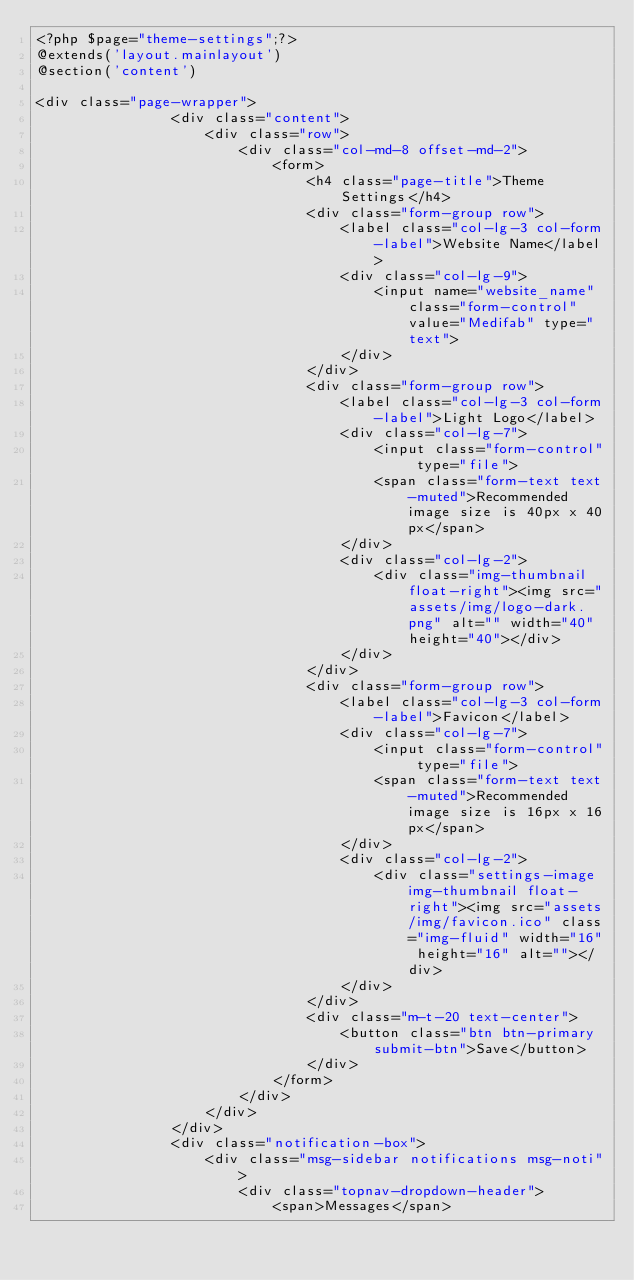Convert code to text. <code><loc_0><loc_0><loc_500><loc_500><_PHP_><?php $page="theme-settings";?>
@extends('layout.mainlayout')
@section('content')		

<div class="page-wrapper">
				<div class="content">
					<div class="row">
						<div class="col-md-8 offset-md-2">
							<form>
								<h4 class="page-title">Theme Settings</h4>
								<div class="form-group row">
									<label class="col-lg-3 col-form-label">Website Name</label>
									<div class="col-lg-9">
										<input name="website_name" class="form-control" value="Medifab" type="text">
									</div>
								</div>
								<div class="form-group row">
									<label class="col-lg-3 col-form-label">Light Logo</label>
									<div class="col-lg-7">
										<input class="form-control" type="file">
										<span class="form-text text-muted">Recommended image size is 40px x 40px</span>
									</div>
									<div class="col-lg-2">
										<div class="img-thumbnail float-right"><img src="assets/img/logo-dark.png" alt="" width="40" height="40"></div>
									</div>
								</div>
								<div class="form-group row">
									<label class="col-lg-3 col-form-label">Favicon</label>
									<div class="col-lg-7">
										<input class="form-control" type="file">
										<span class="form-text text-muted">Recommended image size is 16px x 16px</span>
									</div>
									<div class="col-lg-2">
										<div class="settings-image img-thumbnail float-right"><img src="assets/img/favicon.ico" class="img-fluid" width="16" height="16" alt=""></div>
									</div>
								</div>
								<div class="m-t-20 text-center">
									<button class="btn btn-primary submit-btn">Save</button>
								</div>
							</form>
						</div>
					</div>
				</div>
				<div class="notification-box">
					<div class="msg-sidebar notifications msg-noti">
						<div class="topnav-dropdown-header">
							<span>Messages</span></code> 